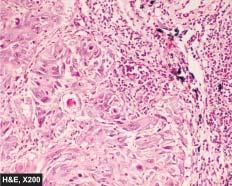re a few well-developed cell nests with keratinisation evident?
Answer the question using a single word or phrase. Yes 